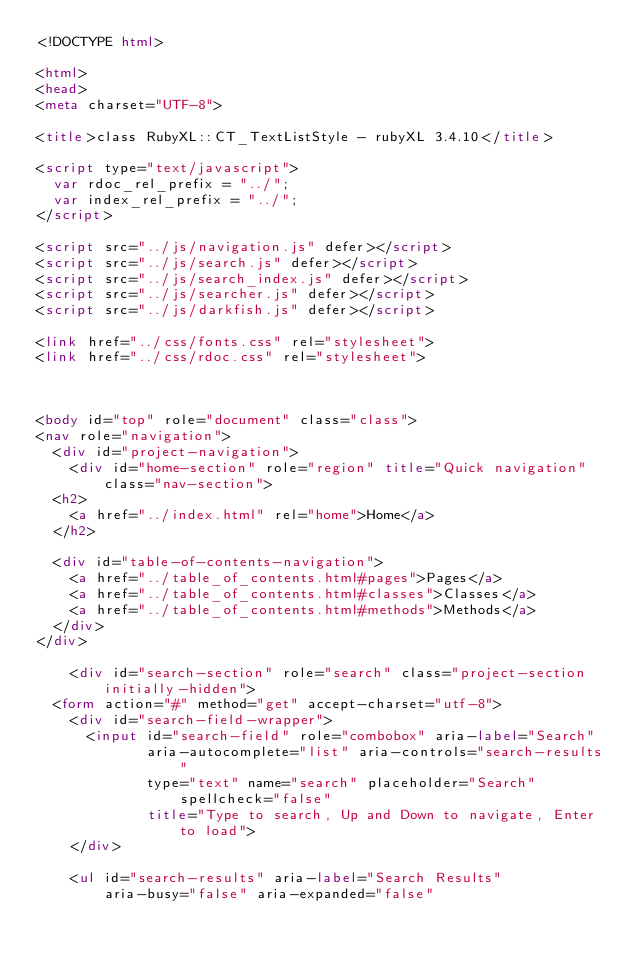<code> <loc_0><loc_0><loc_500><loc_500><_HTML_><!DOCTYPE html>

<html>
<head>
<meta charset="UTF-8">

<title>class RubyXL::CT_TextListStyle - rubyXL 3.4.10</title>

<script type="text/javascript">
  var rdoc_rel_prefix = "../";
  var index_rel_prefix = "../";
</script>

<script src="../js/navigation.js" defer></script>
<script src="../js/search.js" defer></script>
<script src="../js/search_index.js" defer></script>
<script src="../js/searcher.js" defer></script>
<script src="../js/darkfish.js" defer></script>

<link href="../css/fonts.css" rel="stylesheet">
<link href="../css/rdoc.css" rel="stylesheet">



<body id="top" role="document" class="class">
<nav role="navigation">
  <div id="project-navigation">
    <div id="home-section" role="region" title="Quick navigation" class="nav-section">
  <h2>
    <a href="../index.html" rel="home">Home</a>
  </h2>

  <div id="table-of-contents-navigation">
    <a href="../table_of_contents.html#pages">Pages</a>
    <a href="../table_of_contents.html#classes">Classes</a>
    <a href="../table_of_contents.html#methods">Methods</a>
  </div>
</div>

    <div id="search-section" role="search" class="project-section initially-hidden">
  <form action="#" method="get" accept-charset="utf-8">
    <div id="search-field-wrapper">
      <input id="search-field" role="combobox" aria-label="Search"
             aria-autocomplete="list" aria-controls="search-results"
             type="text" name="search" placeholder="Search" spellcheck="false"
             title="Type to search, Up and Down to navigate, Enter to load">
    </div>

    <ul id="search-results" aria-label="Search Results"
        aria-busy="false" aria-expanded="false"</code> 